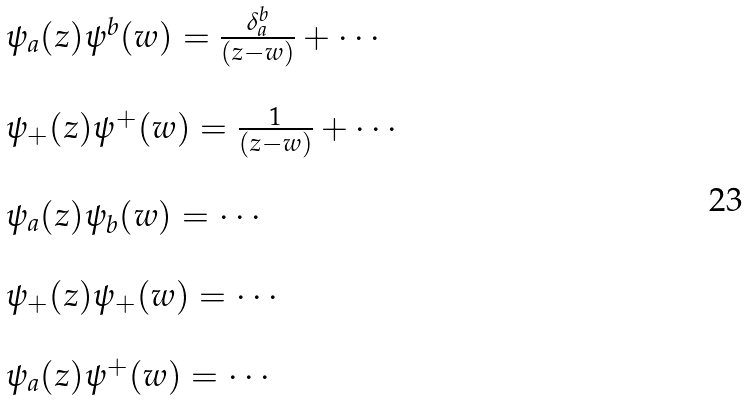Convert formula to latex. <formula><loc_0><loc_0><loc_500><loc_500>\begin{array} { l } \psi _ { a } ( z ) \psi ^ { b } ( w ) = \frac { \delta _ { a } ^ { b } } { ( z - w ) } + \cdots \\ \ \\ \psi _ { + } ( z ) \psi ^ { + } ( w ) = \frac { 1 } { ( z - w ) } + \cdots \\ \ \\ \psi _ { a } ( z ) \psi _ { b } ( w ) = \cdots \\ \ \\ \psi _ { + } ( z ) \psi _ { + } ( w ) = \cdots \\ \ \\ \psi _ { a } ( z ) \psi ^ { + } ( w ) = \cdots \end{array}</formula> 